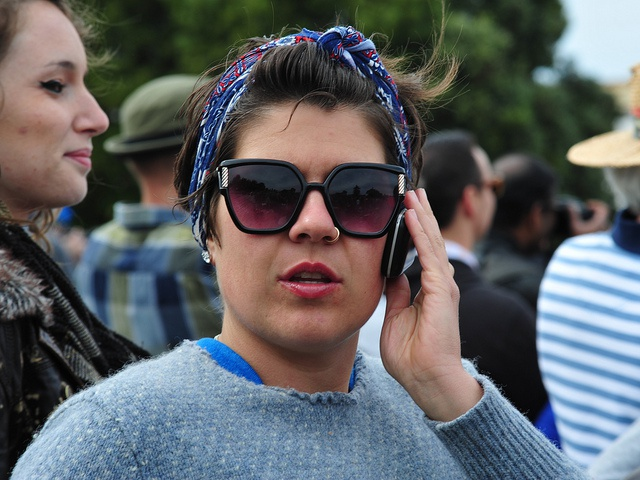Describe the objects in this image and their specific colors. I can see people in gray, black, and brown tones, people in gray, black, and darkgray tones, people in gray, black, and darkgray tones, people in gray, lavender, lightblue, and darkgray tones, and people in gray and black tones in this image. 